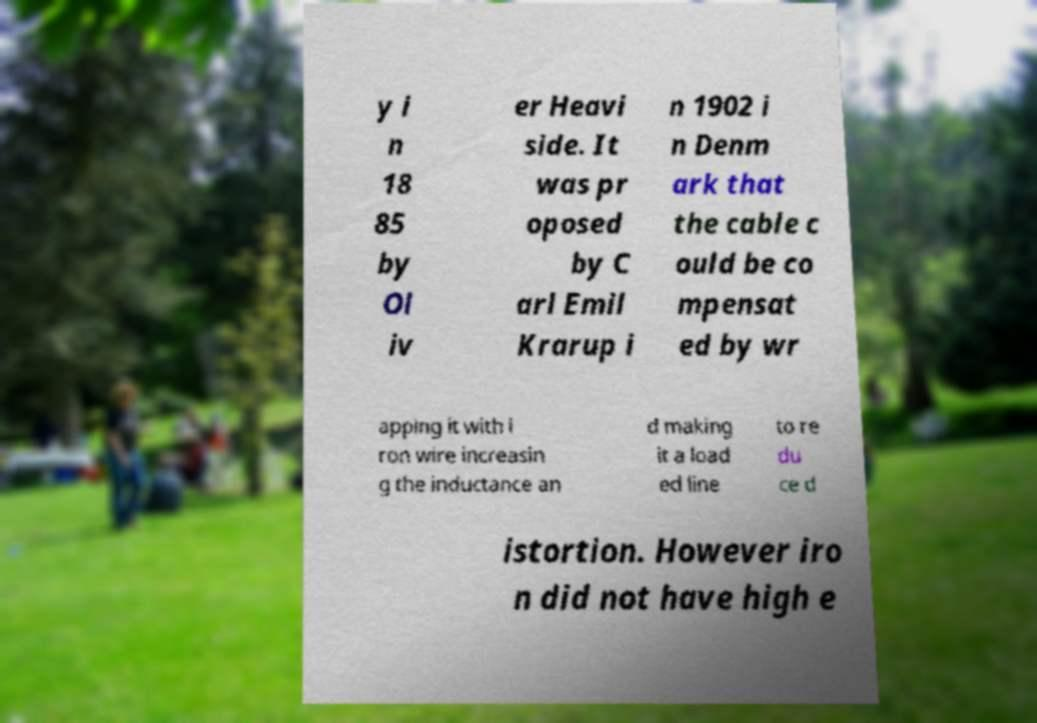Could you extract and type out the text from this image? y i n 18 85 by Ol iv er Heavi side. It was pr oposed by C arl Emil Krarup i n 1902 i n Denm ark that the cable c ould be co mpensat ed by wr apping it with i ron wire increasin g the inductance an d making it a load ed line to re du ce d istortion. However iro n did not have high e 